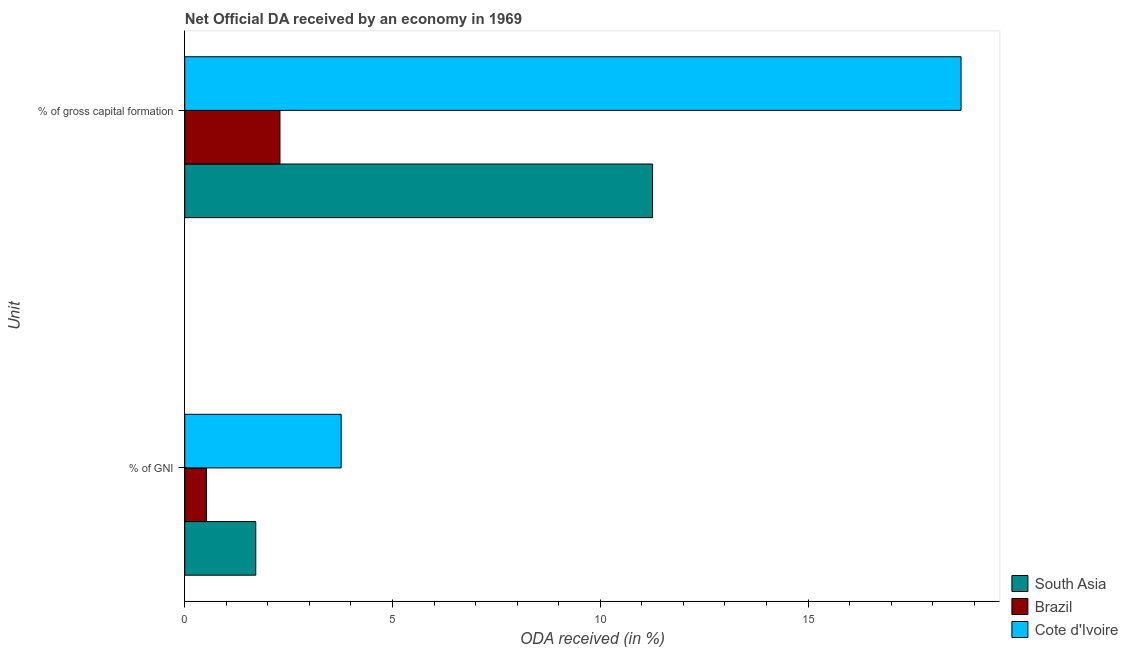How many different coloured bars are there?
Ensure brevity in your answer.  3. How many groups of bars are there?
Your answer should be very brief. 2. Are the number of bars per tick equal to the number of legend labels?
Give a very brief answer. Yes. How many bars are there on the 1st tick from the bottom?
Offer a very short reply. 3. What is the label of the 1st group of bars from the top?
Provide a short and direct response. % of gross capital formation. What is the oda received as percentage of gni in South Asia?
Provide a succinct answer. 1.71. Across all countries, what is the maximum oda received as percentage of gni?
Ensure brevity in your answer.  3.76. Across all countries, what is the minimum oda received as percentage of gross capital formation?
Provide a short and direct response. 2.29. In which country was the oda received as percentage of gni maximum?
Ensure brevity in your answer.  Cote d'Ivoire. In which country was the oda received as percentage of gross capital formation minimum?
Keep it short and to the point. Brazil. What is the total oda received as percentage of gross capital formation in the graph?
Your answer should be compact. 32.23. What is the difference between the oda received as percentage of gni in South Asia and that in Brazil?
Offer a very short reply. 1.19. What is the difference between the oda received as percentage of gross capital formation in Cote d'Ivoire and the oda received as percentage of gni in South Asia?
Provide a succinct answer. 16.97. What is the average oda received as percentage of gross capital formation per country?
Provide a succinct answer. 10.74. What is the difference between the oda received as percentage of gni and oda received as percentage of gross capital formation in South Asia?
Provide a short and direct response. -9.55. In how many countries, is the oda received as percentage of gross capital formation greater than 13 %?
Keep it short and to the point. 1. What is the ratio of the oda received as percentage of gross capital formation in Cote d'Ivoire to that in Brazil?
Offer a very short reply. 8.15. In how many countries, is the oda received as percentage of gross capital formation greater than the average oda received as percentage of gross capital formation taken over all countries?
Offer a very short reply. 2. What does the 1st bar from the top in % of gross capital formation represents?
Offer a very short reply. Cote d'Ivoire. What does the 3rd bar from the bottom in % of gross capital formation represents?
Your answer should be very brief. Cote d'Ivoire. How many bars are there?
Offer a very short reply. 6. How many countries are there in the graph?
Provide a succinct answer. 3. What is the difference between two consecutive major ticks on the X-axis?
Offer a terse response. 5. Are the values on the major ticks of X-axis written in scientific E-notation?
Give a very brief answer. No. Does the graph contain grids?
Give a very brief answer. No. How many legend labels are there?
Provide a short and direct response. 3. What is the title of the graph?
Offer a terse response. Net Official DA received by an economy in 1969. Does "Nicaragua" appear as one of the legend labels in the graph?
Your answer should be very brief. No. What is the label or title of the X-axis?
Your answer should be compact. ODA received (in %). What is the label or title of the Y-axis?
Your response must be concise. Unit. What is the ODA received (in %) in South Asia in % of GNI?
Provide a succinct answer. 1.71. What is the ODA received (in %) of Brazil in % of GNI?
Provide a succinct answer. 0.52. What is the ODA received (in %) in Cote d'Ivoire in % of GNI?
Make the answer very short. 3.76. What is the ODA received (in %) in South Asia in % of gross capital formation?
Provide a short and direct response. 11.26. What is the ODA received (in %) of Brazil in % of gross capital formation?
Your response must be concise. 2.29. What is the ODA received (in %) in Cote d'Ivoire in % of gross capital formation?
Offer a very short reply. 18.68. Across all Unit, what is the maximum ODA received (in %) in South Asia?
Provide a short and direct response. 11.26. Across all Unit, what is the maximum ODA received (in %) of Brazil?
Your response must be concise. 2.29. Across all Unit, what is the maximum ODA received (in %) in Cote d'Ivoire?
Offer a very short reply. 18.68. Across all Unit, what is the minimum ODA received (in %) in South Asia?
Your answer should be compact. 1.71. Across all Unit, what is the minimum ODA received (in %) in Brazil?
Provide a short and direct response. 0.52. Across all Unit, what is the minimum ODA received (in %) in Cote d'Ivoire?
Your response must be concise. 3.76. What is the total ODA received (in %) in South Asia in the graph?
Offer a terse response. 12.97. What is the total ODA received (in %) of Brazil in the graph?
Ensure brevity in your answer.  2.81. What is the total ODA received (in %) in Cote d'Ivoire in the graph?
Provide a succinct answer. 22.45. What is the difference between the ODA received (in %) of South Asia in % of GNI and that in % of gross capital formation?
Your answer should be compact. -9.55. What is the difference between the ODA received (in %) in Brazil in % of GNI and that in % of gross capital formation?
Offer a terse response. -1.77. What is the difference between the ODA received (in %) of Cote d'Ivoire in % of GNI and that in % of gross capital formation?
Keep it short and to the point. -14.92. What is the difference between the ODA received (in %) of South Asia in % of GNI and the ODA received (in %) of Brazil in % of gross capital formation?
Offer a very short reply. -0.58. What is the difference between the ODA received (in %) in South Asia in % of GNI and the ODA received (in %) in Cote d'Ivoire in % of gross capital formation?
Keep it short and to the point. -16.97. What is the difference between the ODA received (in %) of Brazil in % of GNI and the ODA received (in %) of Cote d'Ivoire in % of gross capital formation?
Make the answer very short. -18.16. What is the average ODA received (in %) in South Asia per Unit?
Your response must be concise. 6.48. What is the average ODA received (in %) of Brazil per Unit?
Offer a very short reply. 1.41. What is the average ODA received (in %) of Cote d'Ivoire per Unit?
Your answer should be compact. 11.22. What is the difference between the ODA received (in %) of South Asia and ODA received (in %) of Brazil in % of GNI?
Make the answer very short. 1.19. What is the difference between the ODA received (in %) of South Asia and ODA received (in %) of Cote d'Ivoire in % of GNI?
Your answer should be very brief. -2.05. What is the difference between the ODA received (in %) of Brazil and ODA received (in %) of Cote d'Ivoire in % of GNI?
Give a very brief answer. -3.24. What is the difference between the ODA received (in %) of South Asia and ODA received (in %) of Brazil in % of gross capital formation?
Give a very brief answer. 8.97. What is the difference between the ODA received (in %) in South Asia and ODA received (in %) in Cote d'Ivoire in % of gross capital formation?
Provide a short and direct response. -7.42. What is the difference between the ODA received (in %) of Brazil and ODA received (in %) of Cote d'Ivoire in % of gross capital formation?
Your answer should be very brief. -16.39. What is the ratio of the ODA received (in %) in South Asia in % of GNI to that in % of gross capital formation?
Your answer should be very brief. 0.15. What is the ratio of the ODA received (in %) of Brazil in % of GNI to that in % of gross capital formation?
Ensure brevity in your answer.  0.23. What is the ratio of the ODA received (in %) in Cote d'Ivoire in % of GNI to that in % of gross capital formation?
Your response must be concise. 0.2. What is the difference between the highest and the second highest ODA received (in %) in South Asia?
Keep it short and to the point. 9.55. What is the difference between the highest and the second highest ODA received (in %) in Brazil?
Keep it short and to the point. 1.77. What is the difference between the highest and the second highest ODA received (in %) of Cote d'Ivoire?
Give a very brief answer. 14.92. What is the difference between the highest and the lowest ODA received (in %) of South Asia?
Provide a short and direct response. 9.55. What is the difference between the highest and the lowest ODA received (in %) of Brazil?
Your answer should be very brief. 1.77. What is the difference between the highest and the lowest ODA received (in %) of Cote d'Ivoire?
Provide a succinct answer. 14.92. 